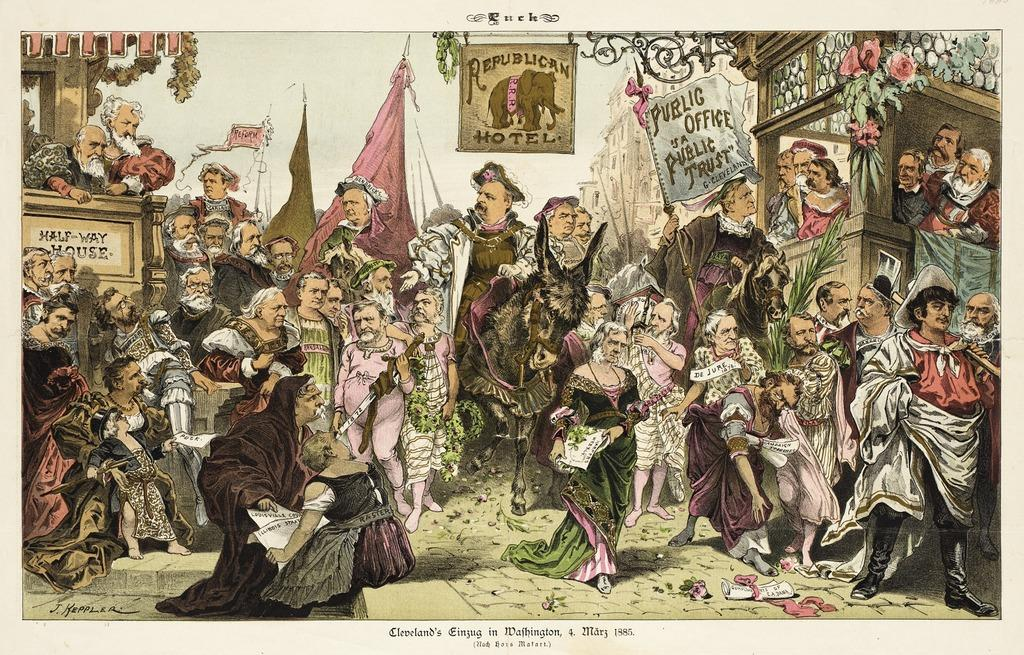<image>
Give a short and clear explanation of the subsequent image. An illustration with a Republican Hotel  flag in a public square. 